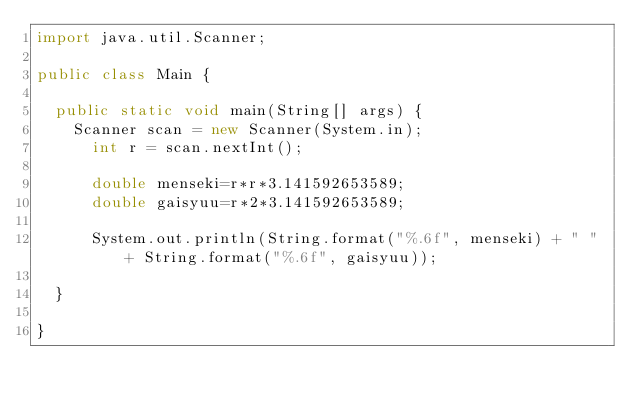<code> <loc_0><loc_0><loc_500><loc_500><_Java_>import java.util.Scanner;

public class Main {

	public static void main(String[] args) {
		Scanner scan = new Scanner(System.in);
	    int r = scan.nextInt();

	    double menseki=r*r*3.141592653589;
	    double gaisyuu=r*2*3.141592653589;

	    System.out.println(String.format("%.6f", menseki) + " " + String.format("%.6f", gaisyuu));

	}

}</code> 